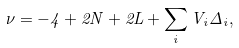Convert formula to latex. <formula><loc_0><loc_0><loc_500><loc_500>\nu = - 4 + 2 N + 2 L + \sum _ { i } V _ { i } \Delta _ { i } ,</formula> 